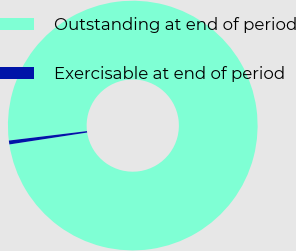<chart> <loc_0><loc_0><loc_500><loc_500><pie_chart><fcel>Outstanding at end of period<fcel>Exercisable at end of period<nl><fcel>99.5%<fcel>0.5%<nl></chart> 